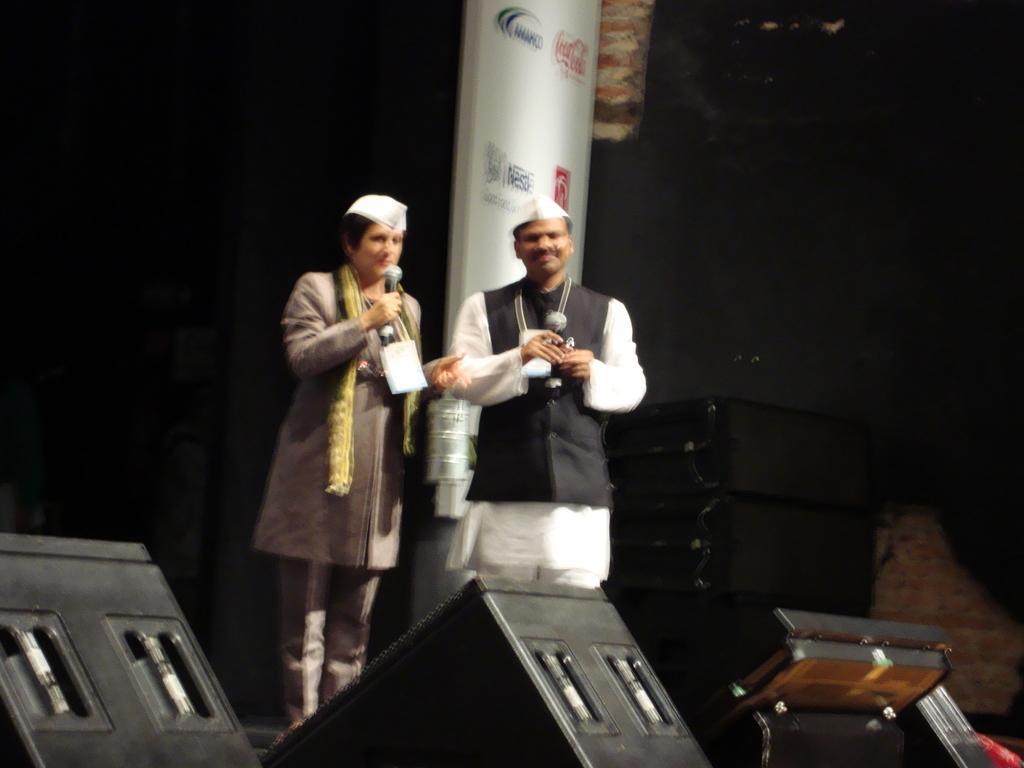Can you describe this image briefly? In this image I can see two persons standing. There are speakers, there is a board and there are some other objects. There is a dark background. 